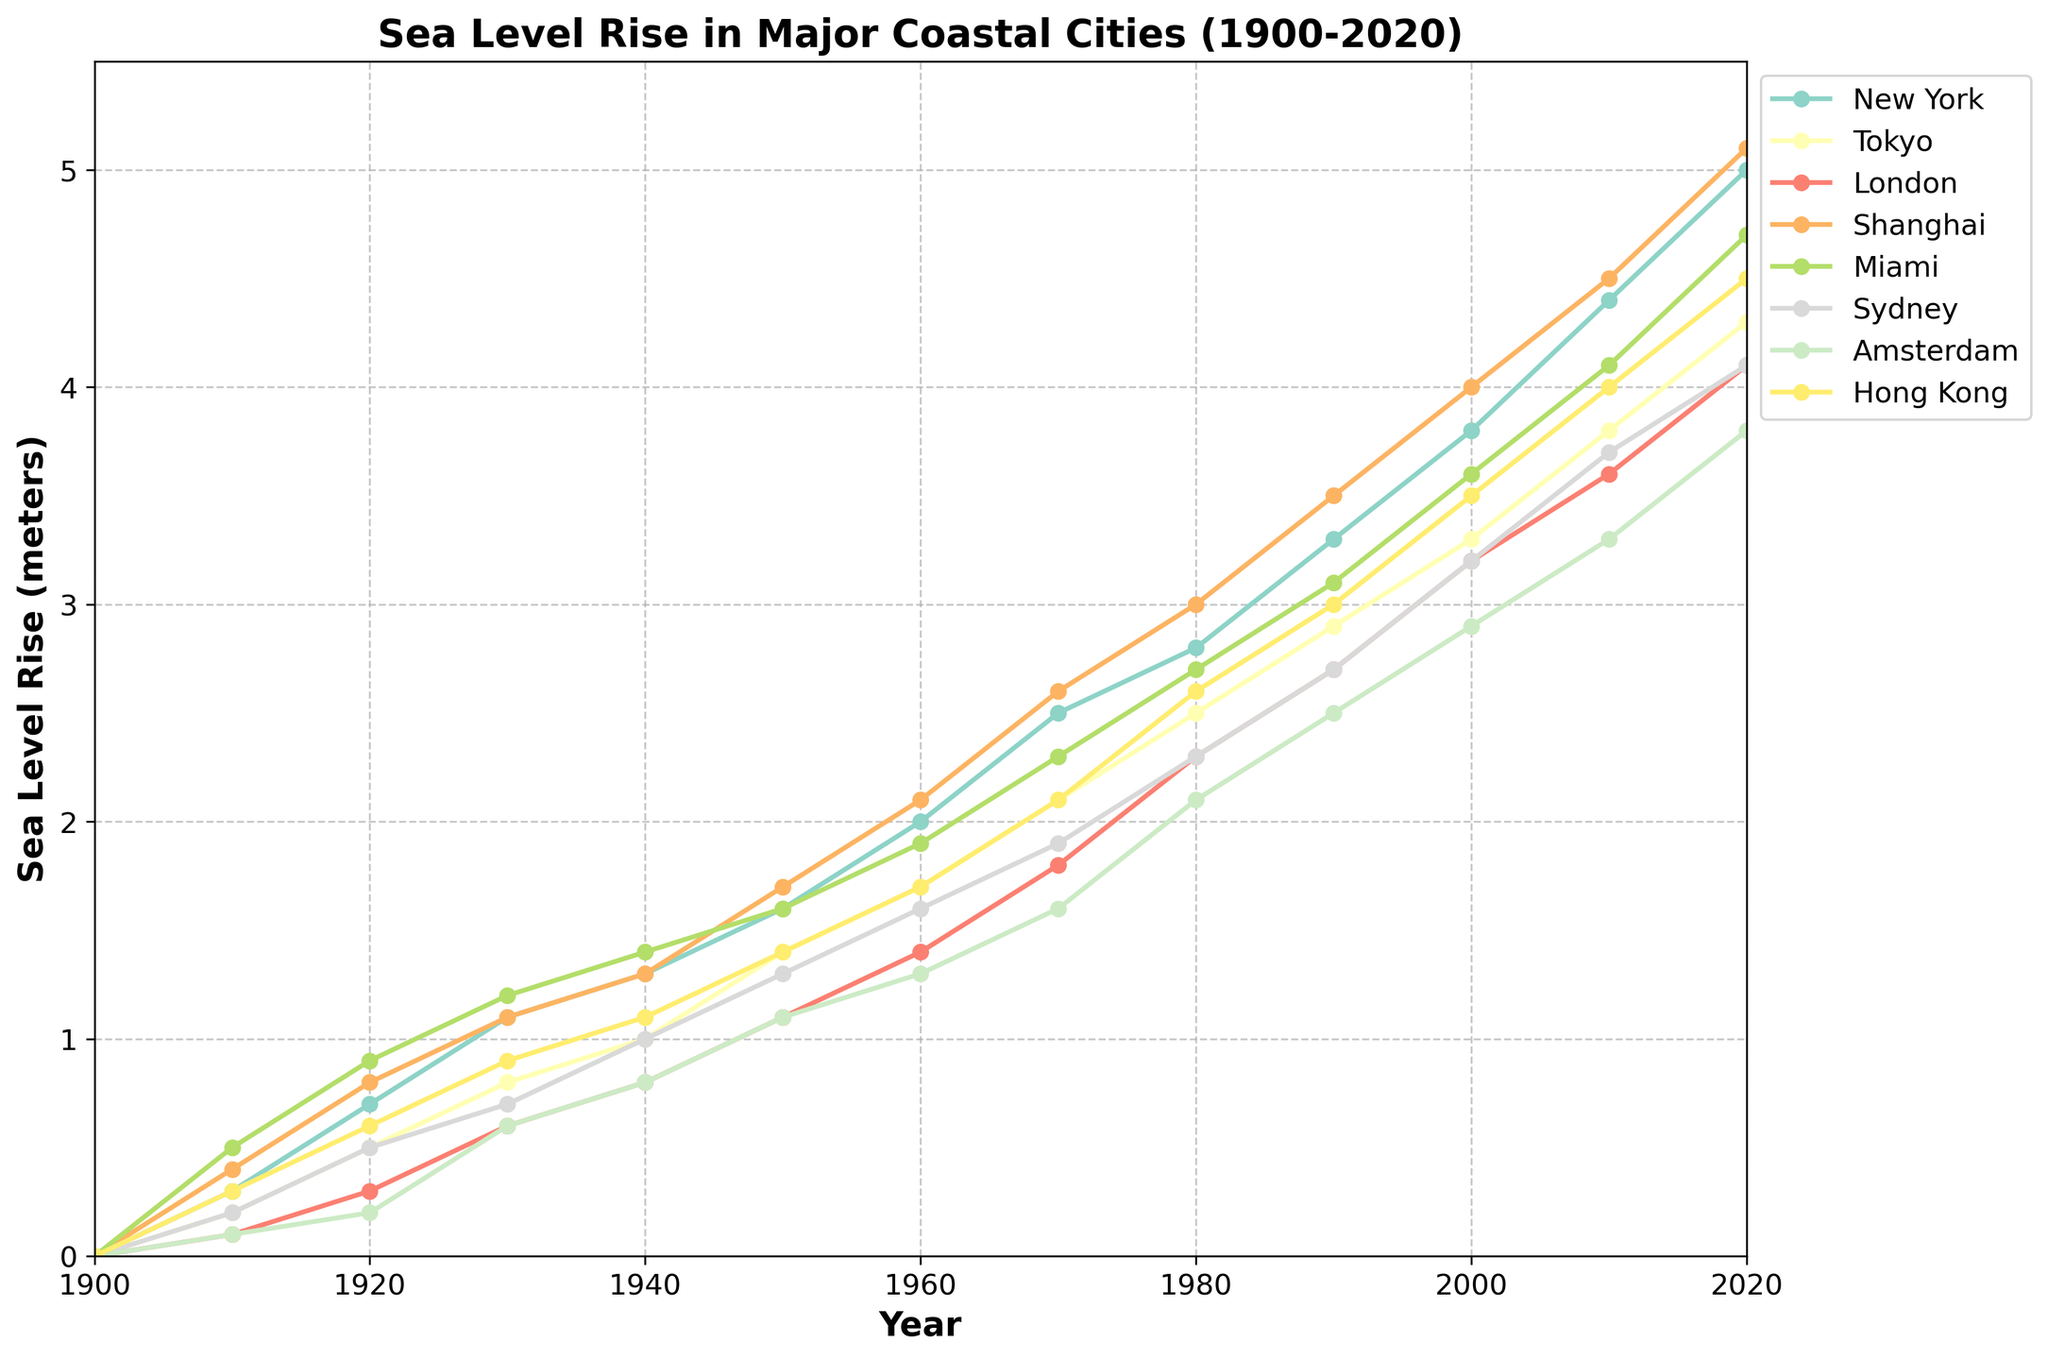Which city experienced the highest sea level rise in 2020? To find the city with the highest sea level rise in 2020, locate the data points for all cities in the year 2020 and find the maximum value.
Answer: New York How much did sea levels rise in Amsterdam from 1900 to 2000? Subtract the sea level rise in Amsterdam in 1900 from that in 2000. The sea level rise in Amsterdam in 2000 was 2.9 meters, and in 1900 it was 0.0 meters. 2.9 - 0.0 = 2.9 meters.
Answer: 2.9 meters Which two cities had the closest sea level rise values in 1970? Compare the sea level rise values for all cities in 1970. The cities with the smallest difference in their values are London (1.8 meters) and Amsterdam (1.6 meters). The difference is 0.2 meters.
Answer: London and Amsterdam What is the average sea level rise for Miami from 1900 to 2020? To find the average, sum the sea level rise values for Miami from 1900 to 2020 and divide by the number of data points. (0.0+0.5+0.9+1.2+1.4+1.6+1.9+2.3+2.7+3.1+3.6+4.1+4.7)/13 ≈ 2.27 meters.
Answer: 2.27 meters Between which consecutive decades did New York experience the largest increase in sea level rise? Calculate the difference in sea levels for each decade and identify the two decades with the largest difference. The largest increase is from 2010 (4.4 meters) to 2020 (5.0 meters), a difference of 0.6 meters.
Answer: 2010 to 2020 Which city's sea level rise first exceeded 2 meters and in which year? Analyze the sea level rise values to find the first instance any city's sea level rise exceeded 2 meters. New York first exceeded 2 meters in 1960 with a rise of 2.0 meters.
Answer: New York, 1960 Whose rise was greater between 2000-2010: Tokyo or Sydney? Calculate the sea level rise from 2000 to 2010 for both Tokyo and Sydney. For Tokyo: 3.8 - 3.3 = 0.5 meters. For Sydney: 3.7 - 3.2 = 0.5 meters. Both cities had the same rise of 0.5 meters.
Answer: Both are equal Did any city have a consistent rise pattern (uniform increase per decade) from 1900 to 2020? To identify a consistent rise pattern, check if any city has an equal increment every decade. For example, Tokyo rises by ~0.3 meters each decade consistently.
Answer: No consistent rise pattern 